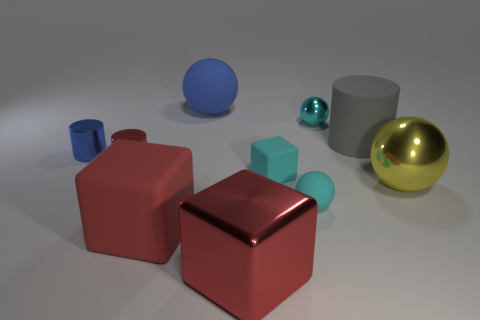Subtract 1 spheres. How many spheres are left? 3 Subtract all green balls. Subtract all yellow cubes. How many balls are left? 4 Subtract all cylinders. How many objects are left? 7 Subtract all tiny yellow rubber objects. Subtract all small blue things. How many objects are left? 9 Add 6 red rubber cubes. How many red rubber cubes are left? 7 Add 6 gray cylinders. How many gray cylinders exist? 7 Subtract 0 purple cylinders. How many objects are left? 10 